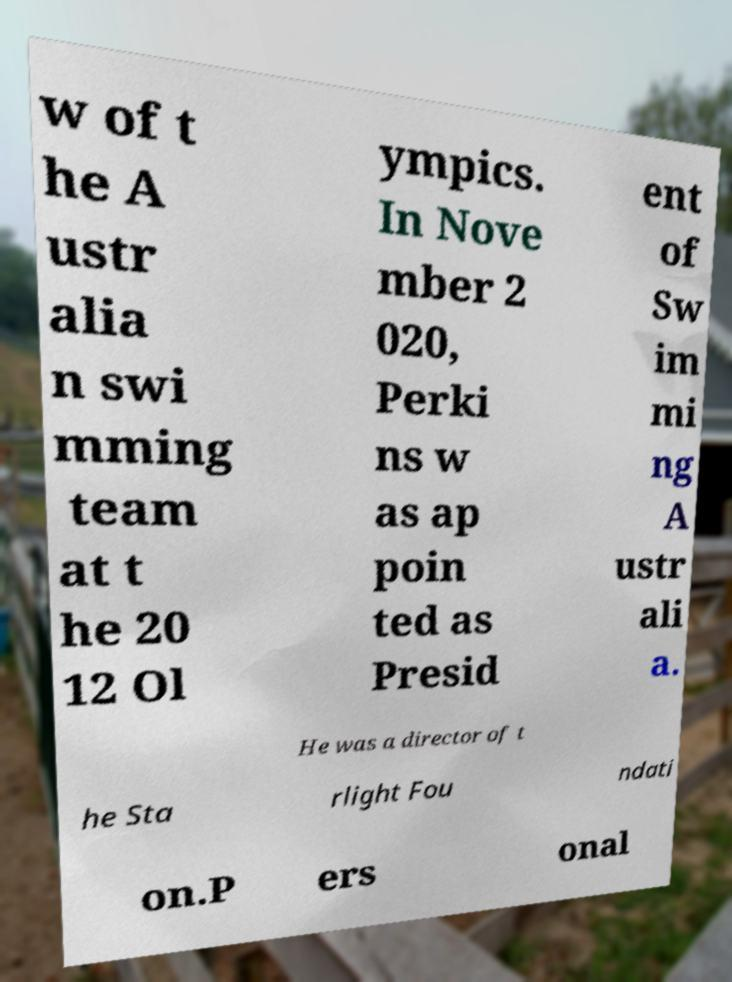Please read and relay the text visible in this image. What does it say? w of t he A ustr alia n swi mming team at t he 20 12 Ol ympics. In Nove mber 2 020, Perki ns w as ap poin ted as Presid ent of Sw im mi ng A ustr ali a. He was a director of t he Sta rlight Fou ndati on.P ers onal 